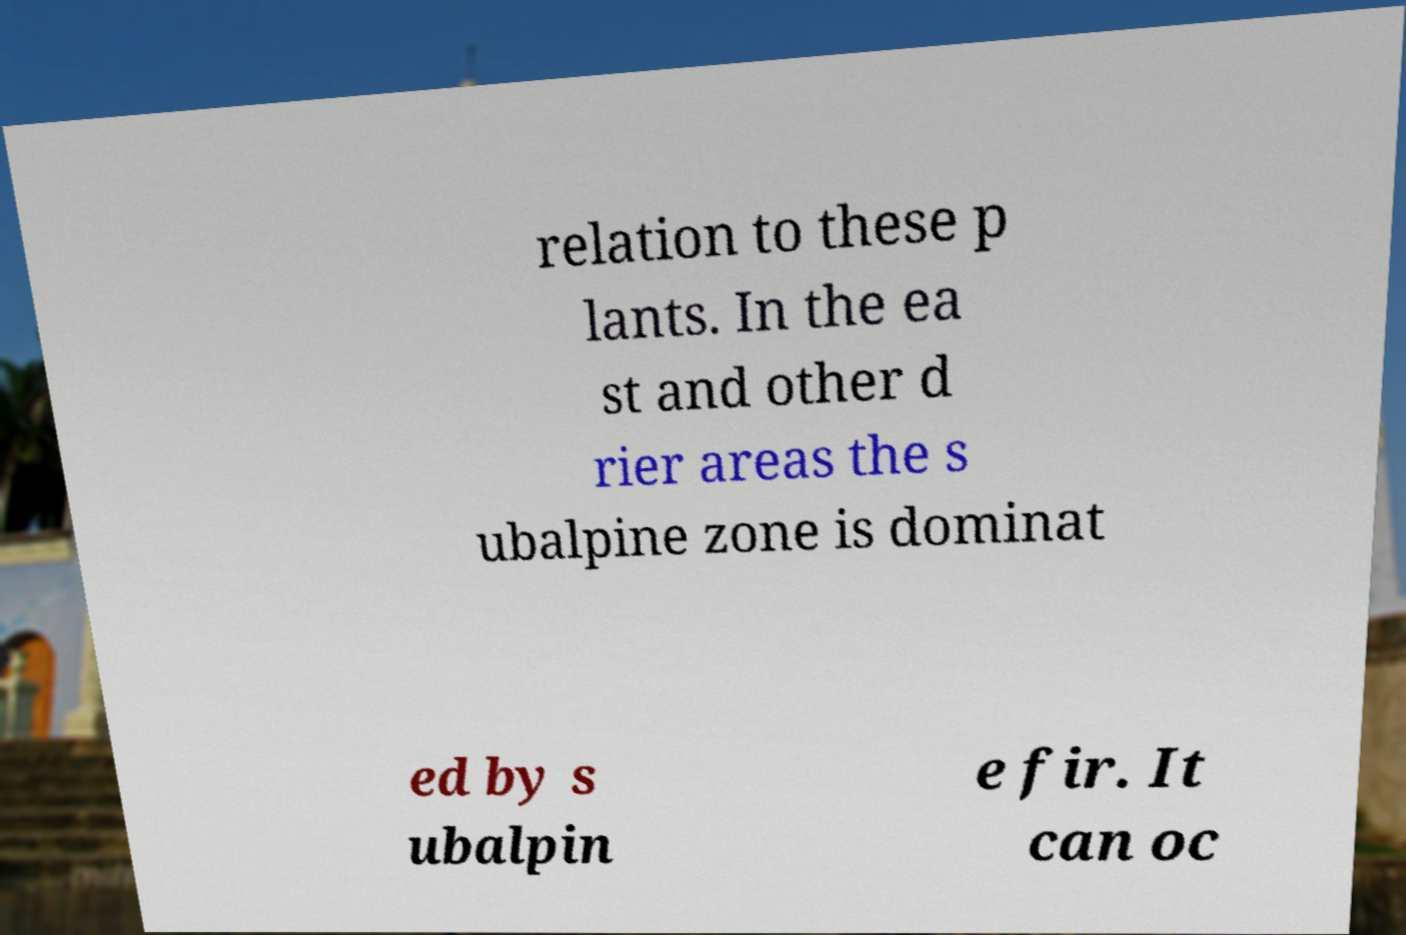Could you assist in decoding the text presented in this image and type it out clearly? relation to these p lants. In the ea st and other d rier areas the s ubalpine zone is dominat ed by s ubalpin e fir. It can oc 